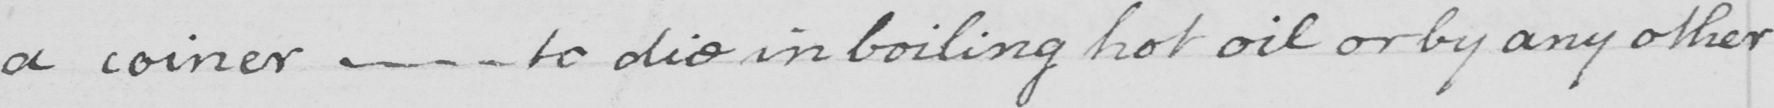What is written in this line of handwriting? a coiner  _   _   _  to die in boiling hot oil or by any other 